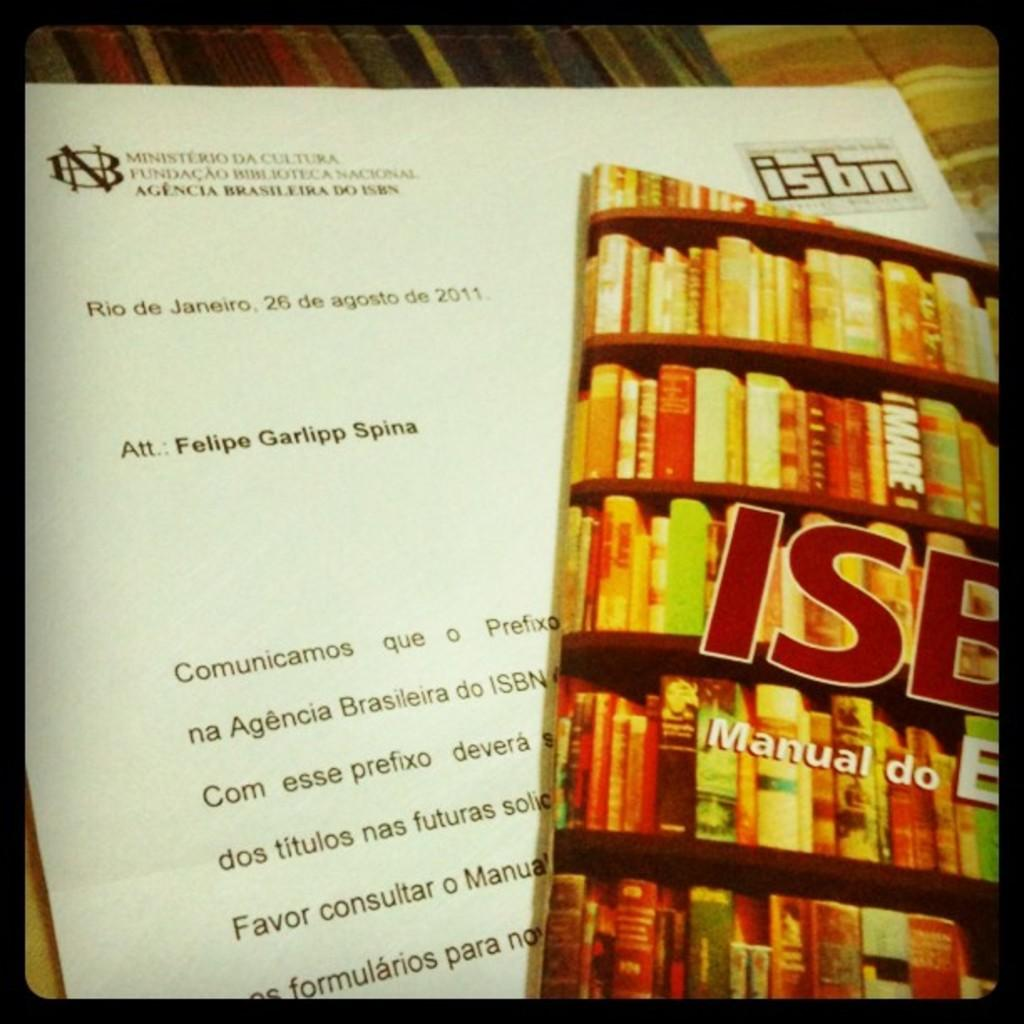<image>
Relay a brief, clear account of the picture shown. a note written to a felipe garlipp spina written in portugese. 